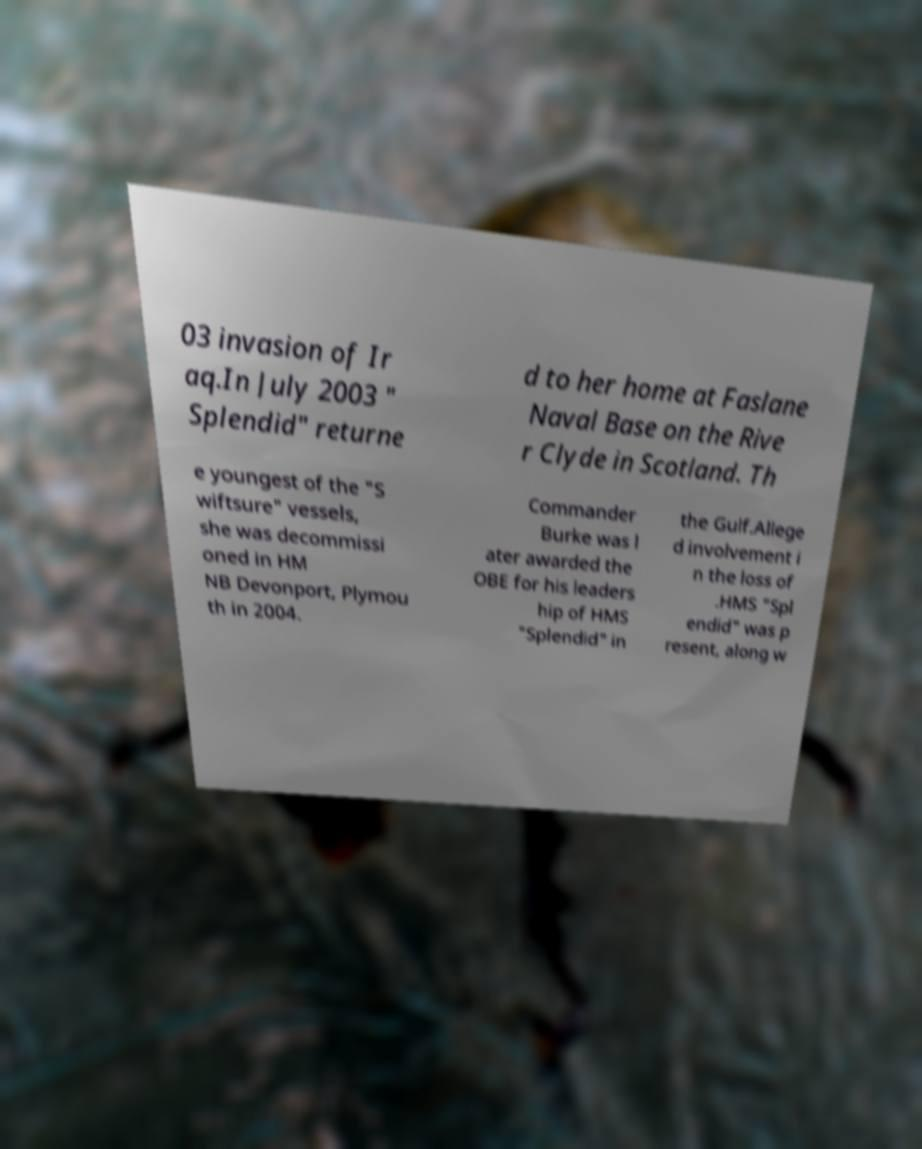There's text embedded in this image that I need extracted. Can you transcribe it verbatim? 03 invasion of Ir aq.In July 2003 " Splendid" returne d to her home at Faslane Naval Base on the Rive r Clyde in Scotland. Th e youngest of the "S wiftsure" vessels, she was decommissi oned in HM NB Devonport, Plymou th in 2004. Commander Burke was l ater awarded the OBE for his leaders hip of HMS "Splendid" in the Gulf.Allege d involvement i n the loss of .HMS "Spl endid" was p resent, along w 